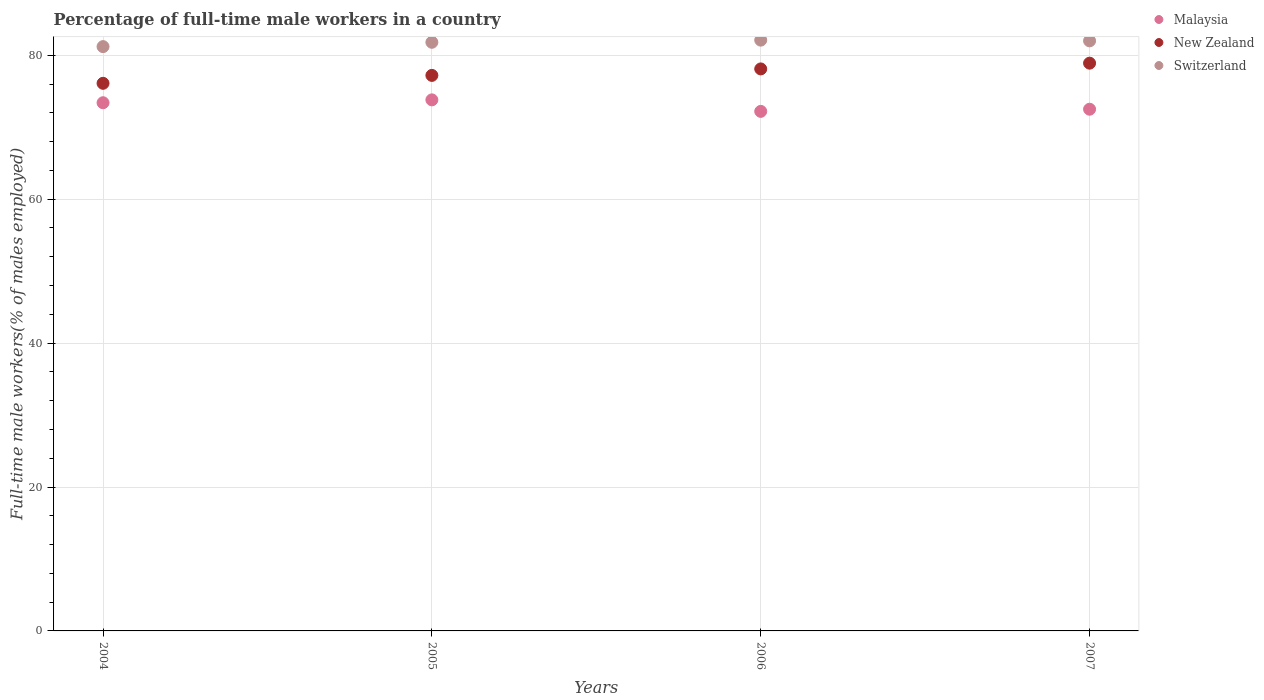What is the percentage of full-time male workers in New Zealand in 2004?
Your answer should be compact. 76.1. Across all years, what is the maximum percentage of full-time male workers in New Zealand?
Give a very brief answer. 78.9. Across all years, what is the minimum percentage of full-time male workers in New Zealand?
Keep it short and to the point. 76.1. In which year was the percentage of full-time male workers in New Zealand minimum?
Provide a succinct answer. 2004. What is the total percentage of full-time male workers in Malaysia in the graph?
Keep it short and to the point. 291.9. What is the difference between the percentage of full-time male workers in Malaysia in 2004 and that in 2006?
Offer a terse response. 1.2. What is the difference between the percentage of full-time male workers in New Zealand in 2006 and the percentage of full-time male workers in Switzerland in 2005?
Your answer should be very brief. -3.7. What is the average percentage of full-time male workers in Malaysia per year?
Provide a succinct answer. 72.98. In the year 2007, what is the difference between the percentage of full-time male workers in Malaysia and percentage of full-time male workers in Switzerland?
Your answer should be very brief. -9.5. What is the ratio of the percentage of full-time male workers in Malaysia in 2006 to that in 2007?
Provide a succinct answer. 1. Is the percentage of full-time male workers in New Zealand in 2004 less than that in 2006?
Provide a short and direct response. Yes. Is the difference between the percentage of full-time male workers in Malaysia in 2005 and 2007 greater than the difference between the percentage of full-time male workers in Switzerland in 2005 and 2007?
Keep it short and to the point. Yes. What is the difference between the highest and the second highest percentage of full-time male workers in New Zealand?
Your response must be concise. 0.8. What is the difference between the highest and the lowest percentage of full-time male workers in New Zealand?
Keep it short and to the point. 2.8. Is the sum of the percentage of full-time male workers in Switzerland in 2004 and 2005 greater than the maximum percentage of full-time male workers in New Zealand across all years?
Ensure brevity in your answer.  Yes. Is the percentage of full-time male workers in New Zealand strictly greater than the percentage of full-time male workers in Malaysia over the years?
Give a very brief answer. Yes. Where does the legend appear in the graph?
Provide a succinct answer. Top right. What is the title of the graph?
Provide a succinct answer. Percentage of full-time male workers in a country. What is the label or title of the X-axis?
Make the answer very short. Years. What is the label or title of the Y-axis?
Give a very brief answer. Full-time male workers(% of males employed). What is the Full-time male workers(% of males employed) in Malaysia in 2004?
Ensure brevity in your answer.  73.4. What is the Full-time male workers(% of males employed) in New Zealand in 2004?
Your response must be concise. 76.1. What is the Full-time male workers(% of males employed) in Switzerland in 2004?
Offer a terse response. 81.2. What is the Full-time male workers(% of males employed) of Malaysia in 2005?
Your response must be concise. 73.8. What is the Full-time male workers(% of males employed) in New Zealand in 2005?
Offer a terse response. 77.2. What is the Full-time male workers(% of males employed) in Switzerland in 2005?
Provide a short and direct response. 81.8. What is the Full-time male workers(% of males employed) in Malaysia in 2006?
Provide a short and direct response. 72.2. What is the Full-time male workers(% of males employed) in New Zealand in 2006?
Give a very brief answer. 78.1. What is the Full-time male workers(% of males employed) of Switzerland in 2006?
Your response must be concise. 82.1. What is the Full-time male workers(% of males employed) in Malaysia in 2007?
Offer a terse response. 72.5. What is the Full-time male workers(% of males employed) in New Zealand in 2007?
Keep it short and to the point. 78.9. What is the Full-time male workers(% of males employed) in Switzerland in 2007?
Provide a short and direct response. 82. Across all years, what is the maximum Full-time male workers(% of males employed) of Malaysia?
Ensure brevity in your answer.  73.8. Across all years, what is the maximum Full-time male workers(% of males employed) of New Zealand?
Provide a short and direct response. 78.9. Across all years, what is the maximum Full-time male workers(% of males employed) of Switzerland?
Offer a very short reply. 82.1. Across all years, what is the minimum Full-time male workers(% of males employed) of Malaysia?
Ensure brevity in your answer.  72.2. Across all years, what is the minimum Full-time male workers(% of males employed) in New Zealand?
Your answer should be very brief. 76.1. Across all years, what is the minimum Full-time male workers(% of males employed) in Switzerland?
Your answer should be compact. 81.2. What is the total Full-time male workers(% of males employed) of Malaysia in the graph?
Offer a terse response. 291.9. What is the total Full-time male workers(% of males employed) of New Zealand in the graph?
Ensure brevity in your answer.  310.3. What is the total Full-time male workers(% of males employed) in Switzerland in the graph?
Your response must be concise. 327.1. What is the difference between the Full-time male workers(% of males employed) in New Zealand in 2004 and that in 2005?
Keep it short and to the point. -1.1. What is the difference between the Full-time male workers(% of males employed) in Switzerland in 2004 and that in 2005?
Your response must be concise. -0.6. What is the difference between the Full-time male workers(% of males employed) of Switzerland in 2004 and that in 2006?
Your answer should be very brief. -0.9. What is the difference between the Full-time male workers(% of males employed) in Malaysia in 2004 and that in 2007?
Offer a terse response. 0.9. What is the difference between the Full-time male workers(% of males employed) of New Zealand in 2004 and that in 2007?
Make the answer very short. -2.8. What is the difference between the Full-time male workers(% of males employed) in Switzerland in 2004 and that in 2007?
Your response must be concise. -0.8. What is the difference between the Full-time male workers(% of males employed) in New Zealand in 2005 and that in 2007?
Provide a short and direct response. -1.7. What is the difference between the Full-time male workers(% of males employed) in Switzerland in 2005 and that in 2007?
Offer a very short reply. -0.2. What is the difference between the Full-time male workers(% of males employed) in Malaysia in 2004 and the Full-time male workers(% of males employed) in New Zealand in 2005?
Give a very brief answer. -3.8. What is the difference between the Full-time male workers(% of males employed) in Malaysia in 2004 and the Full-time male workers(% of males employed) in Switzerland in 2005?
Make the answer very short. -8.4. What is the difference between the Full-time male workers(% of males employed) of Malaysia in 2004 and the Full-time male workers(% of males employed) of Switzerland in 2006?
Offer a very short reply. -8.7. What is the difference between the Full-time male workers(% of males employed) of Malaysia in 2004 and the Full-time male workers(% of males employed) of New Zealand in 2007?
Ensure brevity in your answer.  -5.5. What is the difference between the Full-time male workers(% of males employed) of Malaysia in 2004 and the Full-time male workers(% of males employed) of Switzerland in 2007?
Give a very brief answer. -8.6. What is the difference between the Full-time male workers(% of males employed) of Malaysia in 2005 and the Full-time male workers(% of males employed) of New Zealand in 2006?
Give a very brief answer. -4.3. What is the difference between the Full-time male workers(% of males employed) in Malaysia in 2005 and the Full-time male workers(% of males employed) in Switzerland in 2006?
Offer a very short reply. -8.3. What is the difference between the Full-time male workers(% of males employed) of Malaysia in 2005 and the Full-time male workers(% of males employed) of Switzerland in 2007?
Provide a short and direct response. -8.2. What is the difference between the Full-time male workers(% of males employed) of Malaysia in 2006 and the Full-time male workers(% of males employed) of Switzerland in 2007?
Your answer should be very brief. -9.8. What is the average Full-time male workers(% of males employed) of Malaysia per year?
Ensure brevity in your answer.  72.97. What is the average Full-time male workers(% of males employed) of New Zealand per year?
Your answer should be very brief. 77.58. What is the average Full-time male workers(% of males employed) in Switzerland per year?
Offer a terse response. 81.78. In the year 2004, what is the difference between the Full-time male workers(% of males employed) in Malaysia and Full-time male workers(% of males employed) in Switzerland?
Offer a terse response. -7.8. In the year 2005, what is the difference between the Full-time male workers(% of males employed) in Malaysia and Full-time male workers(% of males employed) in New Zealand?
Ensure brevity in your answer.  -3.4. In the year 2005, what is the difference between the Full-time male workers(% of males employed) in Malaysia and Full-time male workers(% of males employed) in Switzerland?
Ensure brevity in your answer.  -8. In the year 2006, what is the difference between the Full-time male workers(% of males employed) in New Zealand and Full-time male workers(% of males employed) in Switzerland?
Give a very brief answer. -4. What is the ratio of the Full-time male workers(% of males employed) in Malaysia in 2004 to that in 2005?
Provide a short and direct response. 0.99. What is the ratio of the Full-time male workers(% of males employed) in New Zealand in 2004 to that in 2005?
Provide a short and direct response. 0.99. What is the ratio of the Full-time male workers(% of males employed) of Switzerland in 2004 to that in 2005?
Your response must be concise. 0.99. What is the ratio of the Full-time male workers(% of males employed) in Malaysia in 2004 to that in 2006?
Your response must be concise. 1.02. What is the ratio of the Full-time male workers(% of males employed) of New Zealand in 2004 to that in 2006?
Offer a terse response. 0.97. What is the ratio of the Full-time male workers(% of males employed) of Malaysia in 2004 to that in 2007?
Provide a succinct answer. 1.01. What is the ratio of the Full-time male workers(% of males employed) in New Zealand in 2004 to that in 2007?
Give a very brief answer. 0.96. What is the ratio of the Full-time male workers(% of males employed) in Switzerland in 2004 to that in 2007?
Ensure brevity in your answer.  0.99. What is the ratio of the Full-time male workers(% of males employed) in Malaysia in 2005 to that in 2006?
Make the answer very short. 1.02. What is the ratio of the Full-time male workers(% of males employed) of New Zealand in 2005 to that in 2006?
Your answer should be compact. 0.99. What is the ratio of the Full-time male workers(% of males employed) in Switzerland in 2005 to that in 2006?
Offer a very short reply. 1. What is the ratio of the Full-time male workers(% of males employed) in Malaysia in 2005 to that in 2007?
Your answer should be very brief. 1.02. What is the ratio of the Full-time male workers(% of males employed) in New Zealand in 2005 to that in 2007?
Ensure brevity in your answer.  0.98. What is the ratio of the Full-time male workers(% of males employed) in Switzerland in 2005 to that in 2007?
Your response must be concise. 1. What is the difference between the highest and the lowest Full-time male workers(% of males employed) of Switzerland?
Your answer should be very brief. 0.9. 